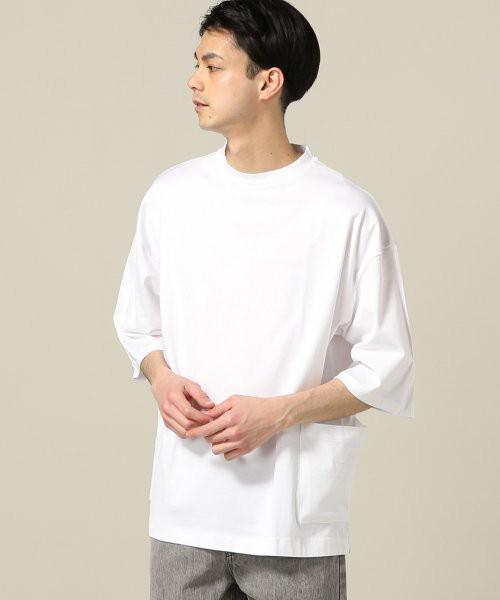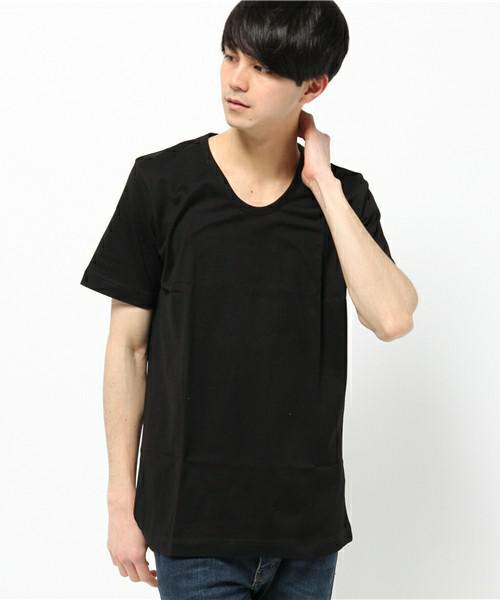The first image is the image on the left, the second image is the image on the right. Analyze the images presented: Is the assertion "The man in the left image is wearing a hat." valid? Answer yes or no. No. The first image is the image on the left, the second image is the image on the right. For the images displayed, is the sentence "One man is wearing something on his head." factually correct? Answer yes or no. No. 